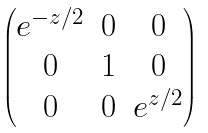Convert formula to latex. <formula><loc_0><loc_0><loc_500><loc_500>\begin{pmatrix} e ^ { - z / 2 } & 0 & 0 \\ 0 & 1 & 0 \\ 0 & 0 & e ^ { z / 2 } \end{pmatrix}</formula> 